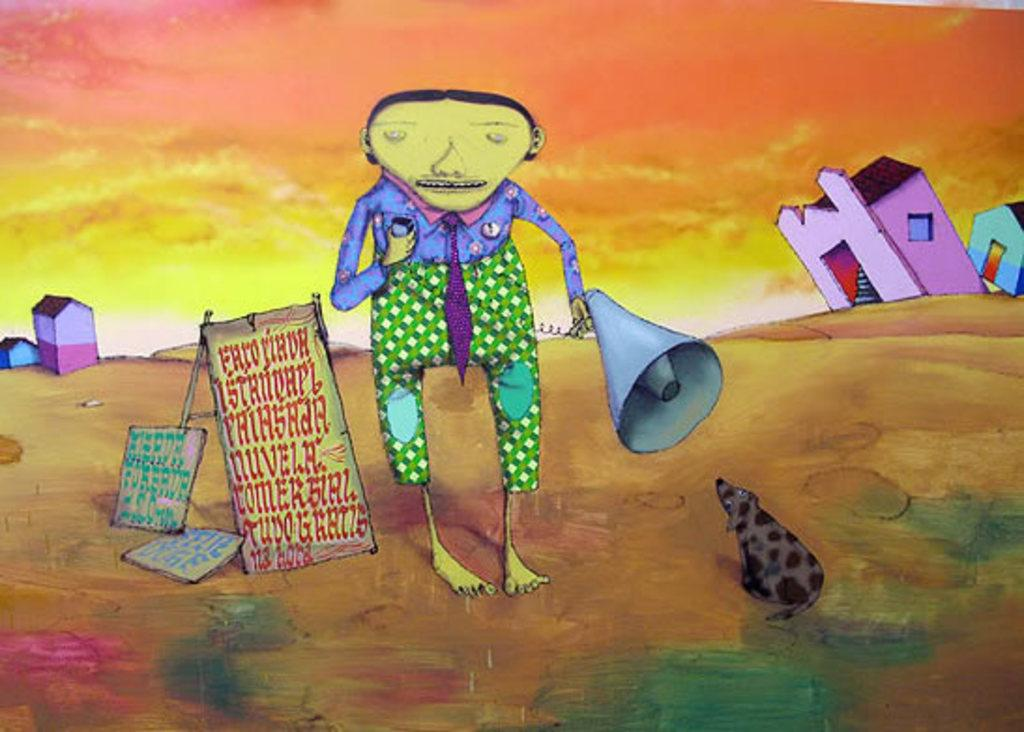What is present in the animated image? There is a person, posters, and houses in the animated image. Can you describe the person in the animated image? Unfortunately, the provided facts do not give any details about the person's appearance or actions. What type of posters are visible in the animated image? The provided facts do not give any details about the content or design of the posters. How many houses are present in the animated image? The provided facts do not specify the number of houses in the image. What type of spoon is being used by the person in the animated image? There is no spoon present in the animated image, as the provided facts only mention a person, posters, and houses. 